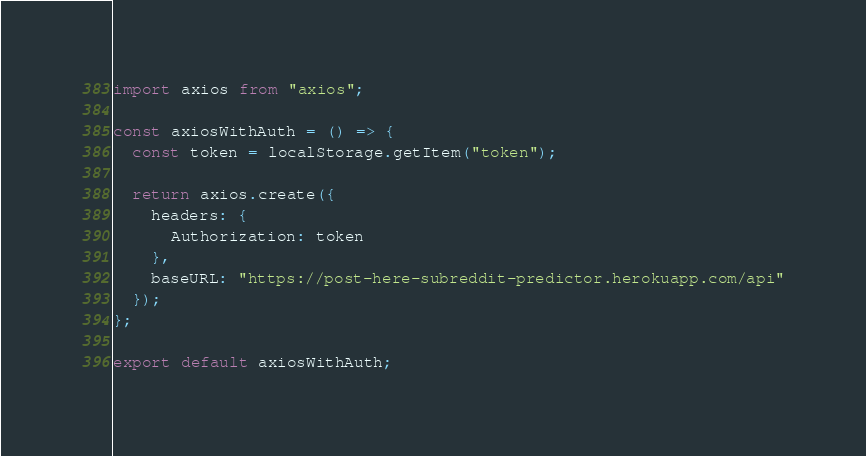<code> <loc_0><loc_0><loc_500><loc_500><_JavaScript_>import axios from "axios";

const axiosWithAuth = () => {
  const token = localStorage.getItem("token");

  return axios.create({
    headers: {
      Authorization: token
    },
    baseURL: "https://post-here-subreddit-predictor.herokuapp.com/api"
  });
};

export default axiosWithAuth;</code> 